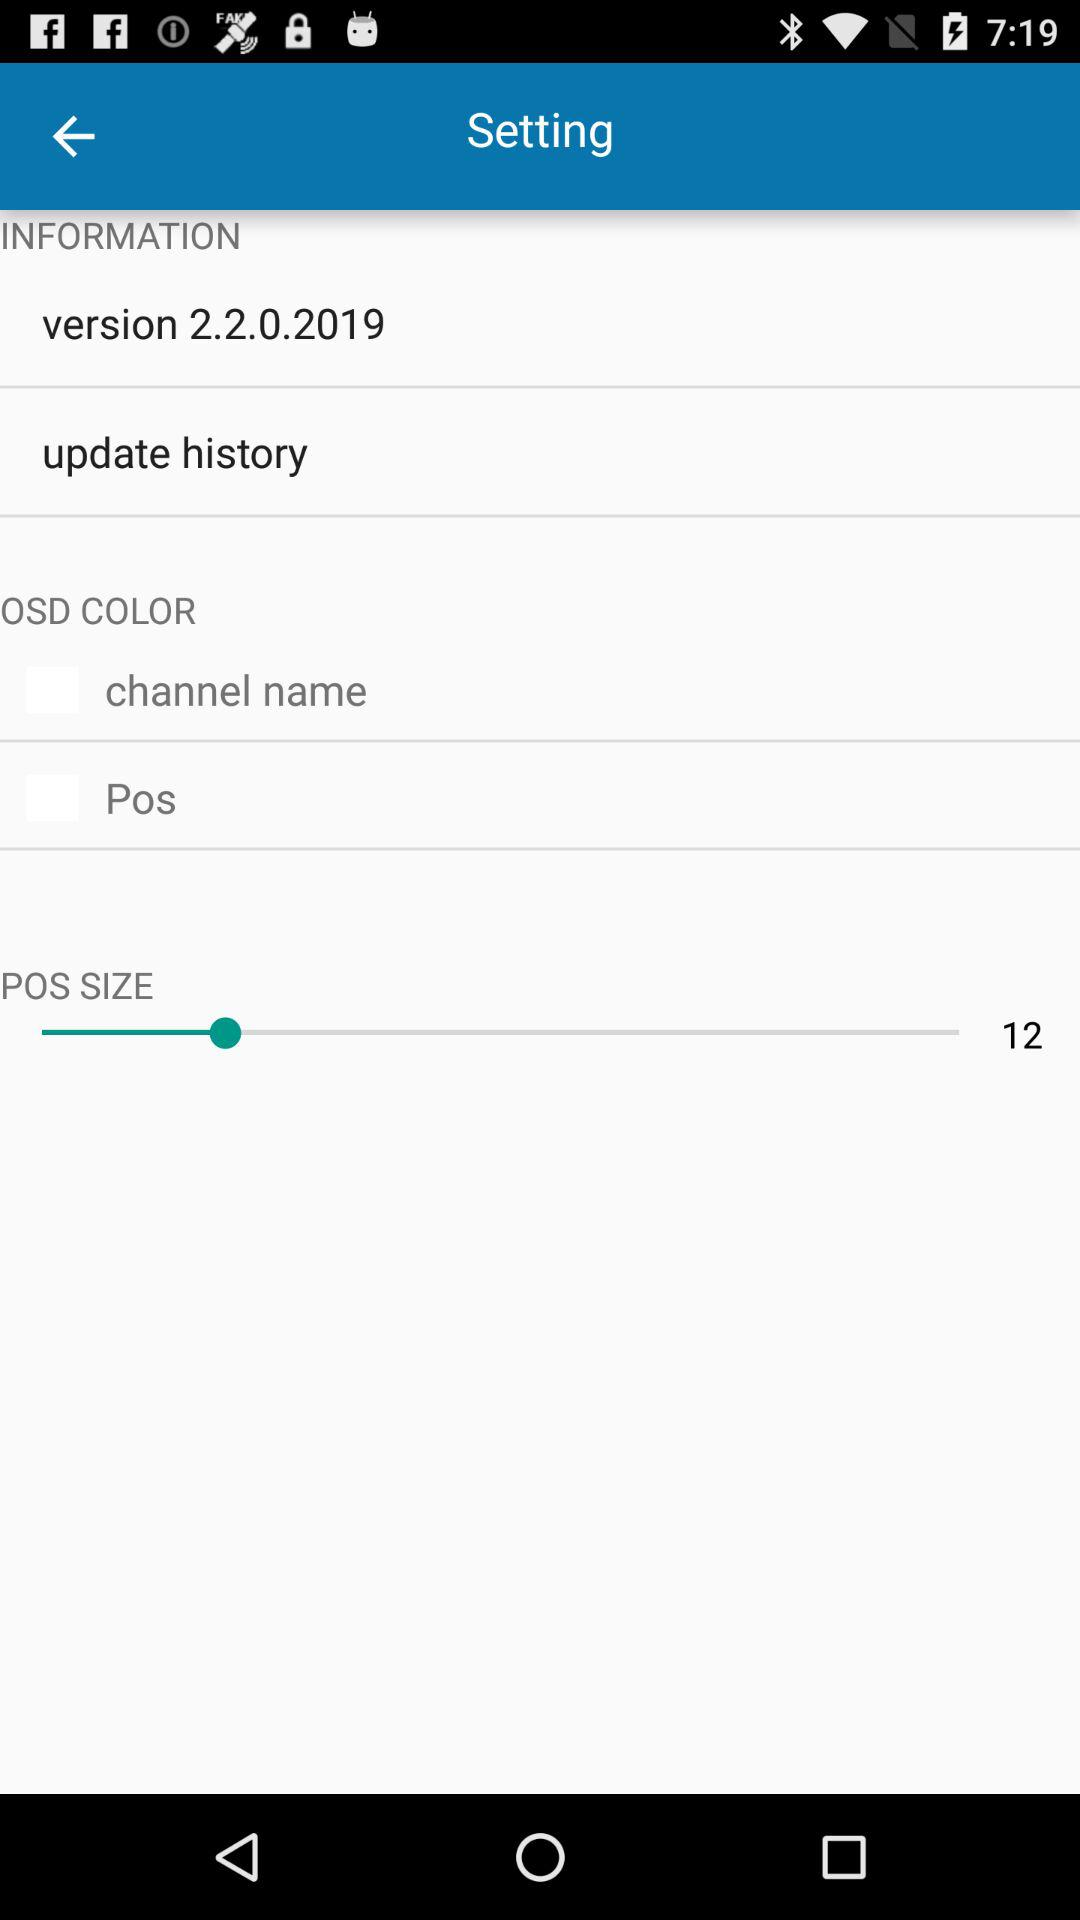What is the status of channel name?
When the provided information is insufficient, respond with <no answer>. <no answer> 